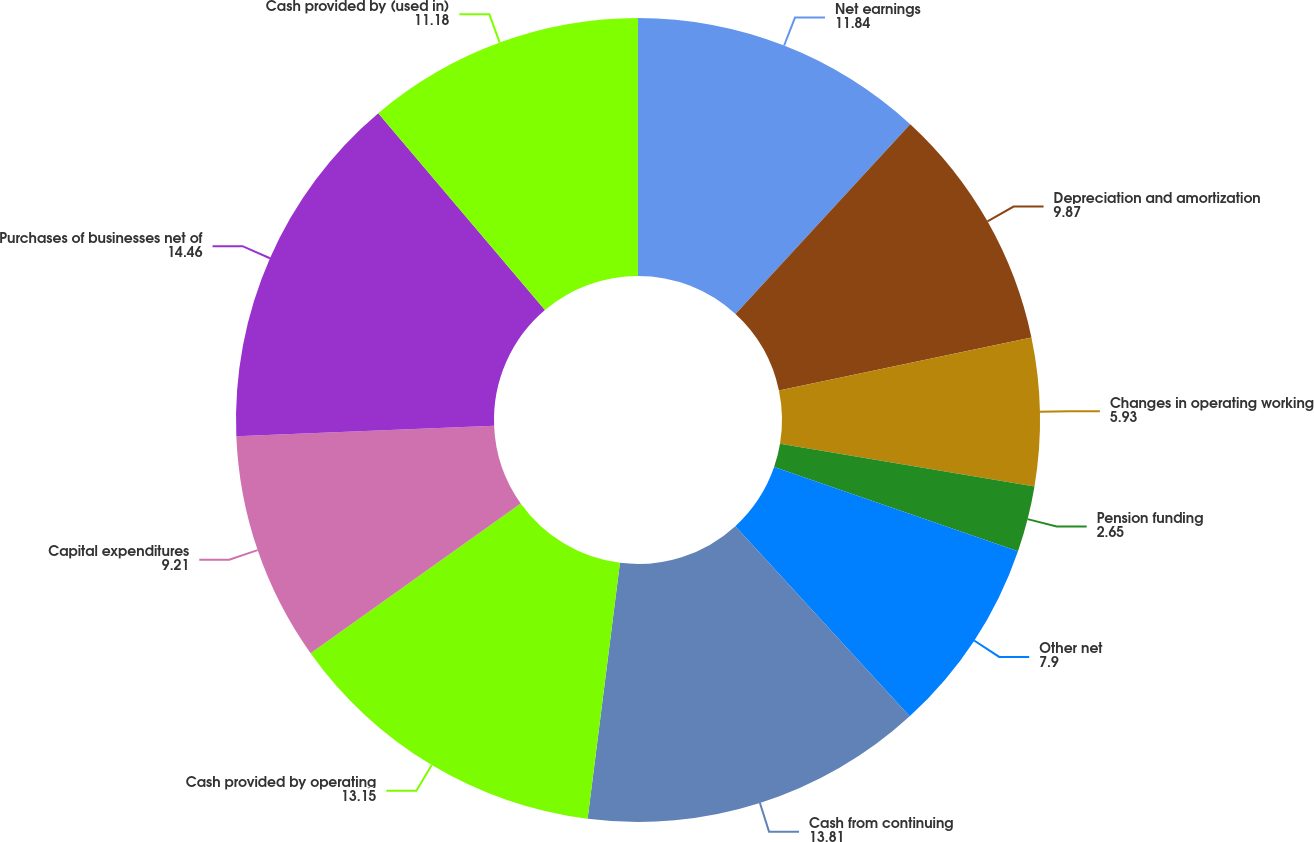Convert chart. <chart><loc_0><loc_0><loc_500><loc_500><pie_chart><fcel>Net earnings<fcel>Depreciation and amortization<fcel>Changes in operating working<fcel>Pension funding<fcel>Other net<fcel>Cash from continuing<fcel>Cash provided by operating<fcel>Capital expenditures<fcel>Purchases of businesses net of<fcel>Cash provided by (used in)<nl><fcel>11.84%<fcel>9.87%<fcel>5.93%<fcel>2.65%<fcel>7.9%<fcel>13.81%<fcel>13.15%<fcel>9.21%<fcel>14.46%<fcel>11.18%<nl></chart> 